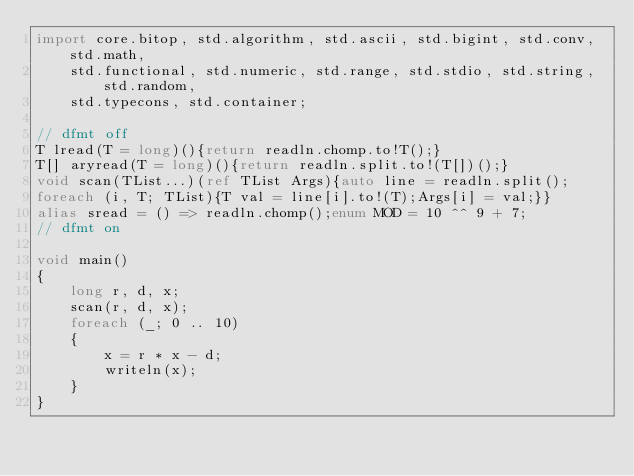Convert code to text. <code><loc_0><loc_0><loc_500><loc_500><_D_>import core.bitop, std.algorithm, std.ascii, std.bigint, std.conv, std.math,
    std.functional, std.numeric, std.range, std.stdio, std.string, std.random,
    std.typecons, std.container;

// dfmt off
T lread(T = long)(){return readln.chomp.to!T();}
T[] aryread(T = long)(){return readln.split.to!(T[])();}
void scan(TList...)(ref TList Args){auto line = readln.split();
foreach (i, T; TList){T val = line[i].to!(T);Args[i] = val;}}
alias sread = () => readln.chomp();enum MOD = 10 ^^ 9 + 7;
// dfmt on

void main()
{
    long r, d, x;
    scan(r, d, x);
    foreach (_; 0 .. 10)
    {
        x = r * x - d;
        writeln(x);
    }
}
</code> 